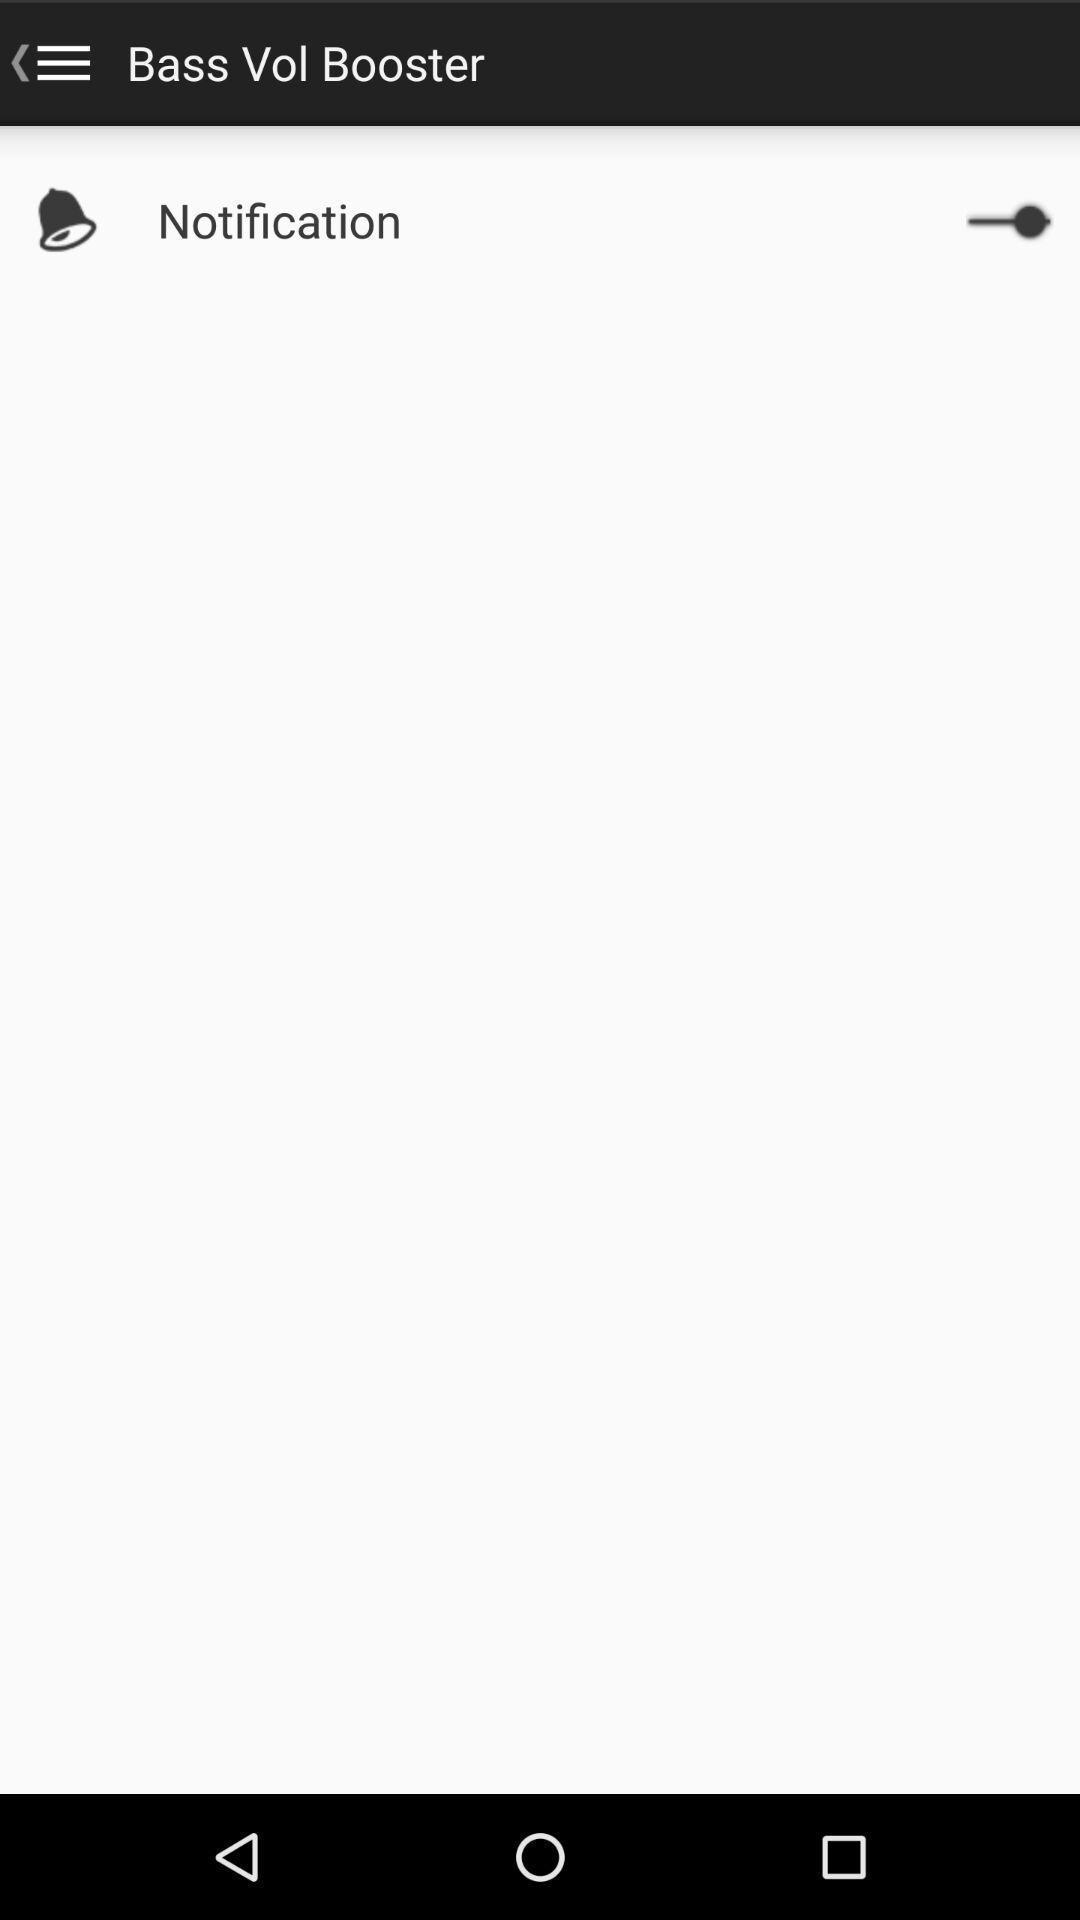What can you discern from this picture? Page showing text about notification. 